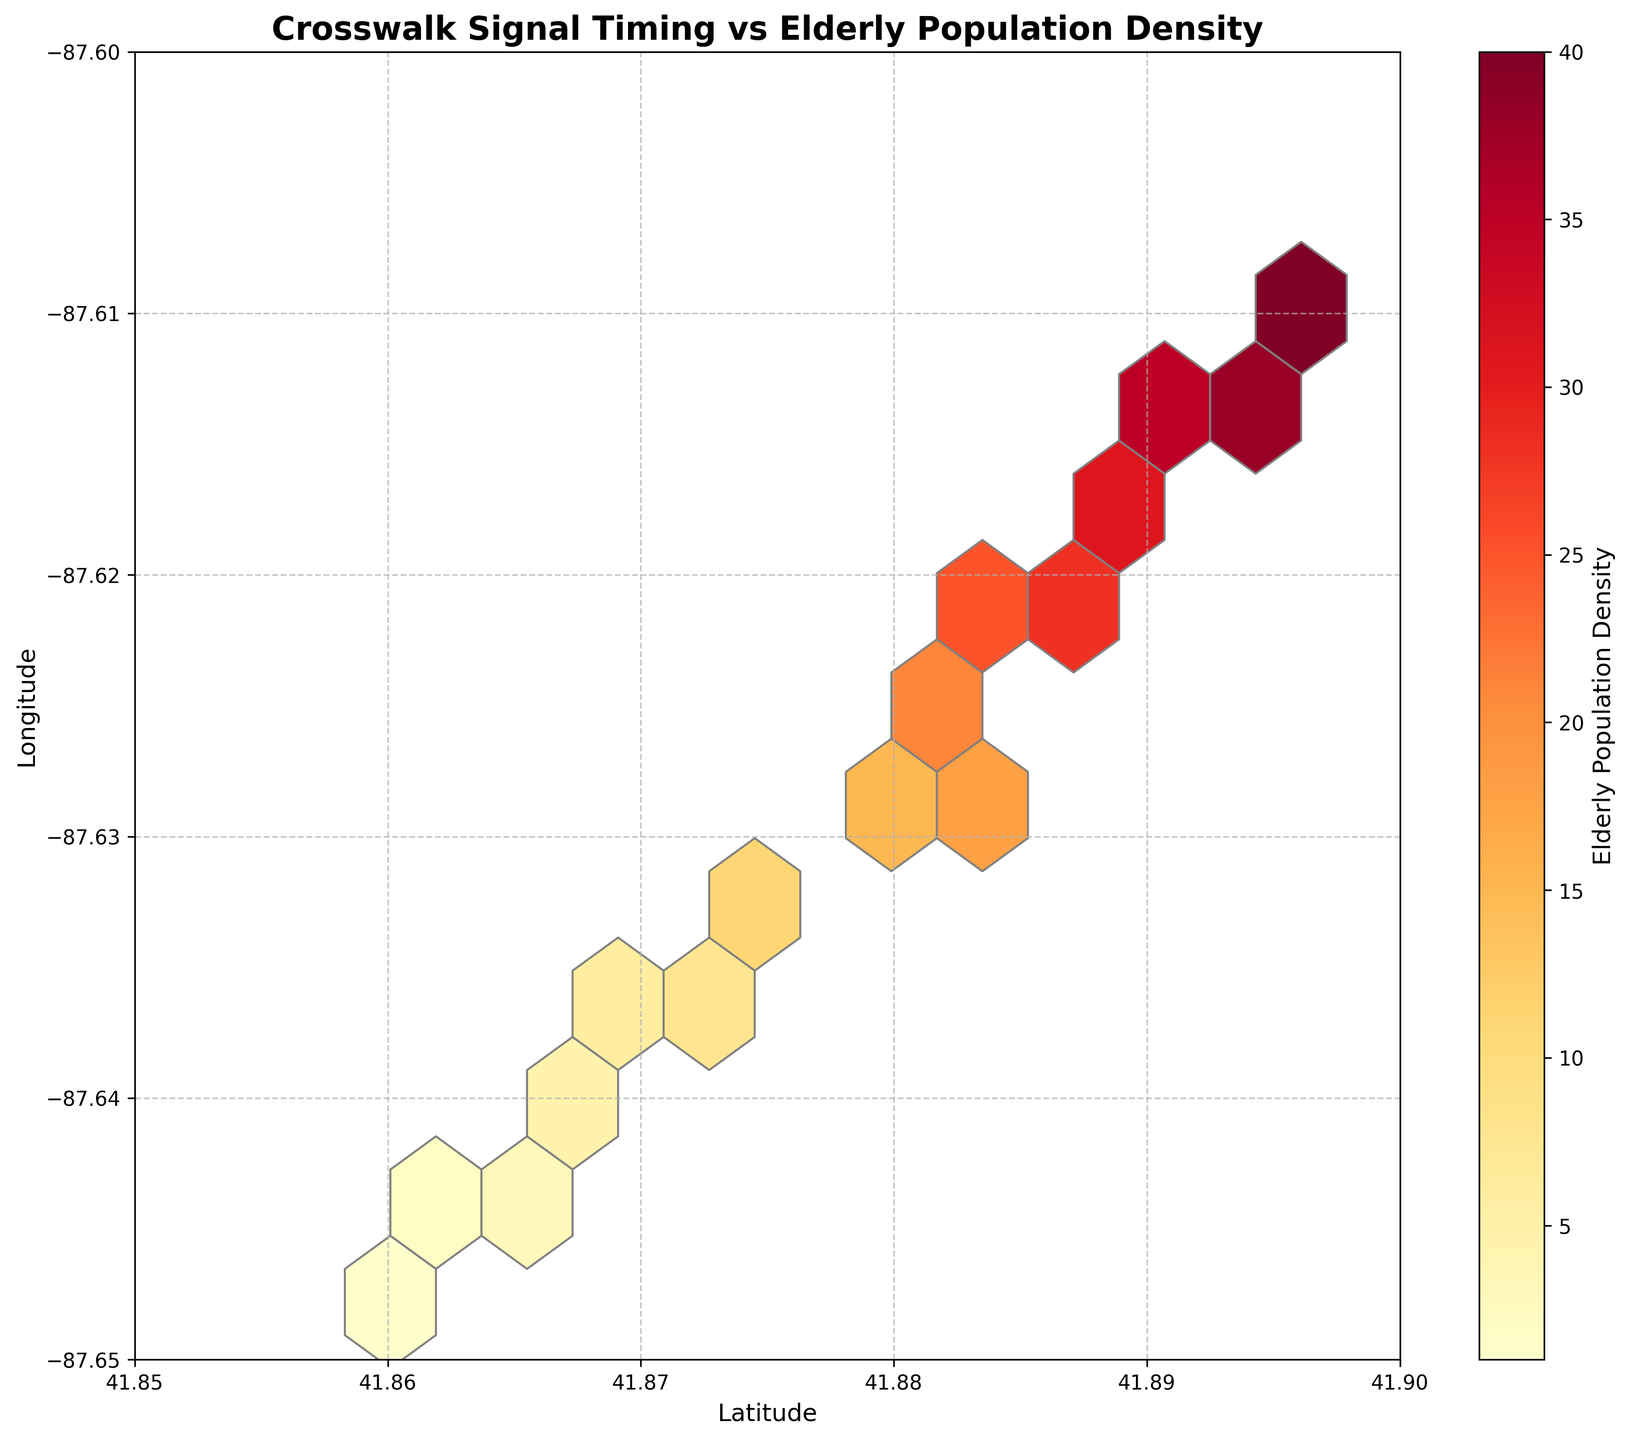How many data points are represented in the figure? Count the hexagon centers representing each data point or check for dots representing data points if displayed. Each hexagon corresponds to a data point.
Answer: 20 What is the color representing the highest elderly population density? Observing the color bar on the side, the color corresponding to the highest numerical value represents the highest density.
Answer: Dark red Which location has the highest density of the elderly population? By looking at the plot and identifying the darkest red hexagon, we locate the corresponding latitude and longitude on the axes.
Answer: (41.8961, -87.6098) What is the title of the figure? The title is usually displayed at the top of the figure.
Answer: Crosswalk Signal Timing vs Elderly Population Density How does the elderly population density change as you move from north to south? Observe the color gradient and the distribution of colors from the top of the plot (north) to the bottom (south).
Answer: Density decreases Which axis represents latitude, and which represents longitude? Typically, latitude is placed on the horizontal (x) axis, and longitude on the vertical (y) axis as per geographic plotting conventions.
Answer: Latitude on x-axis, Longitude on y-axis What is the range of the longitude represented in the plot? Check the labels on the vertical (y) axis to determine the range of values plotted.
Answer: -87.65 to -87.60 Comparing the easternmost and westernmost zones, which one has a higher density of the elderly population? Locate the hexagons at the far east and west edges of the plot, compare their color intensities using the color bar as a reference.
Answer: Easternmost Which area of the city appears to require more attention for improving crosswalk signal timings based on the elderly population density? Identify areas with higher elderly population density (darker hexagons) and suggest that these would need more attention.
Answer: Areas with darkest red hexagons What is the average elderly population density value for the data points provided? Sum the "value" data points and divide by the number of data points: (15 + 18 + 12 + 20 + 10 + 22 + 8 + 25 + 6 + 28 + 5 + 30 + 4 + 32 + 3 + 35 + 2 + 38 + 1 + 40) / 20 = 384 / 20
Answer: 19.2 